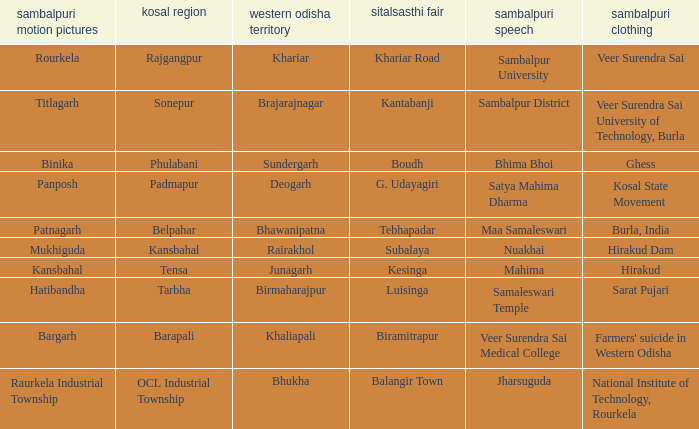What is the sambalpuri saree with a samaleswari temple as sambalpuri language? Sarat Pujari. 